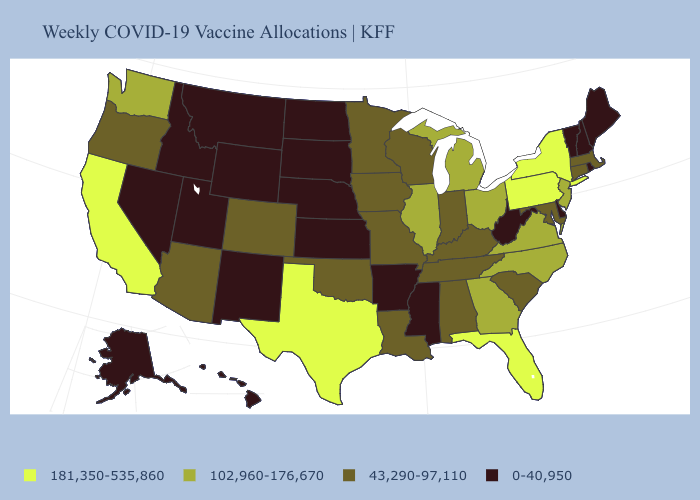What is the value of Oregon?
Short answer required. 43,290-97,110. Does the map have missing data?
Short answer required. No. What is the highest value in states that border Georgia?
Answer briefly. 181,350-535,860. What is the value of Florida?
Concise answer only. 181,350-535,860. Does the map have missing data?
Give a very brief answer. No. What is the value of South Dakota?
Short answer required. 0-40,950. Name the states that have a value in the range 181,350-535,860?
Be succinct. California, Florida, New York, Pennsylvania, Texas. Which states have the lowest value in the USA?
Answer briefly. Alaska, Arkansas, Delaware, Hawaii, Idaho, Kansas, Maine, Mississippi, Montana, Nebraska, Nevada, New Hampshire, New Mexico, North Dakota, Rhode Island, South Dakota, Utah, Vermont, West Virginia, Wyoming. Does Maryland have the lowest value in the USA?
Concise answer only. No. What is the lowest value in the Northeast?
Concise answer only. 0-40,950. Is the legend a continuous bar?
Be succinct. No. Which states have the lowest value in the USA?
Answer briefly. Alaska, Arkansas, Delaware, Hawaii, Idaho, Kansas, Maine, Mississippi, Montana, Nebraska, Nevada, New Hampshire, New Mexico, North Dakota, Rhode Island, South Dakota, Utah, Vermont, West Virginia, Wyoming. Among the states that border Idaho , does Washington have the lowest value?
Short answer required. No. Does Mississippi have the highest value in the South?
Quick response, please. No. Which states have the lowest value in the USA?
Be succinct. Alaska, Arkansas, Delaware, Hawaii, Idaho, Kansas, Maine, Mississippi, Montana, Nebraska, Nevada, New Hampshire, New Mexico, North Dakota, Rhode Island, South Dakota, Utah, Vermont, West Virginia, Wyoming. 